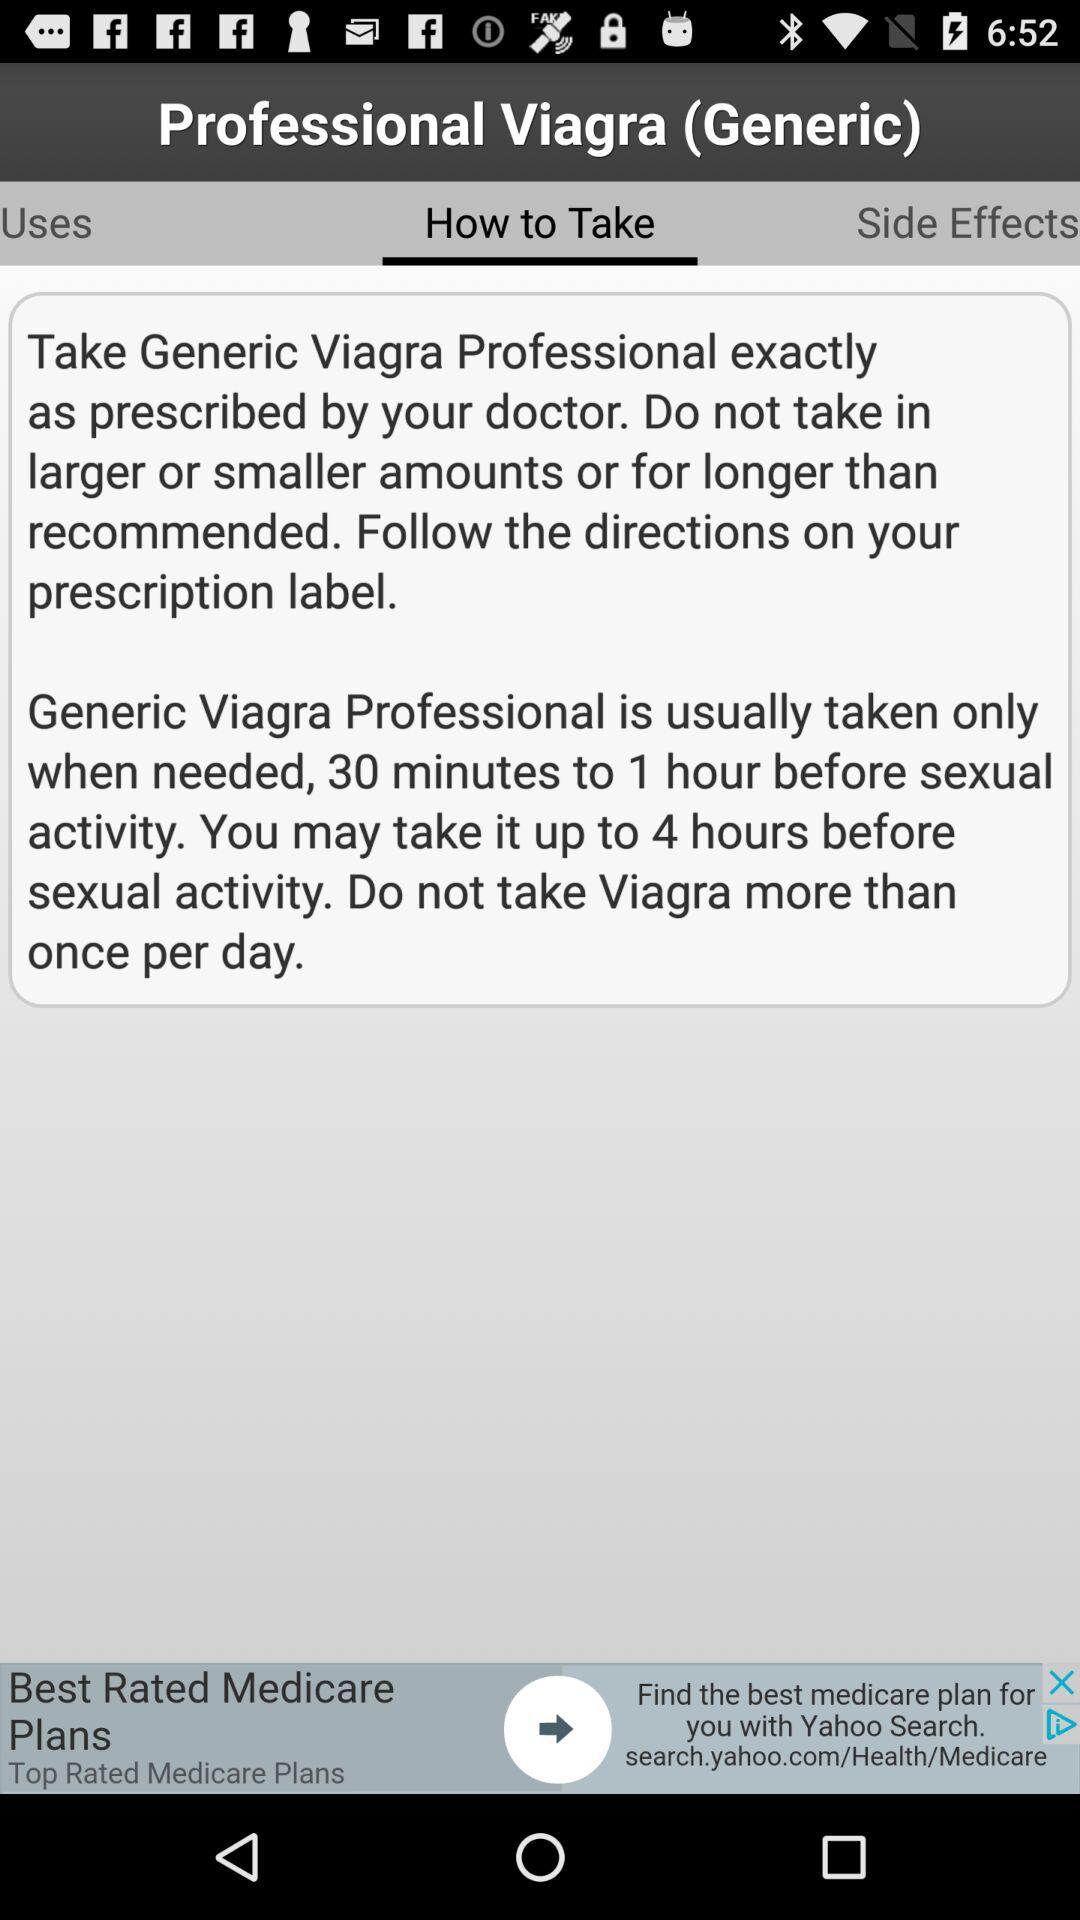Which tab is selected? The selected tab is "How to Take". 